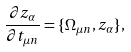Convert formula to latex. <formula><loc_0><loc_0><loc_500><loc_500>\frac { \partial z _ { \alpha } } { \partial t _ { \mu n } } = \{ \Omega _ { \mu n } , z _ { \alpha } \} ,</formula> 